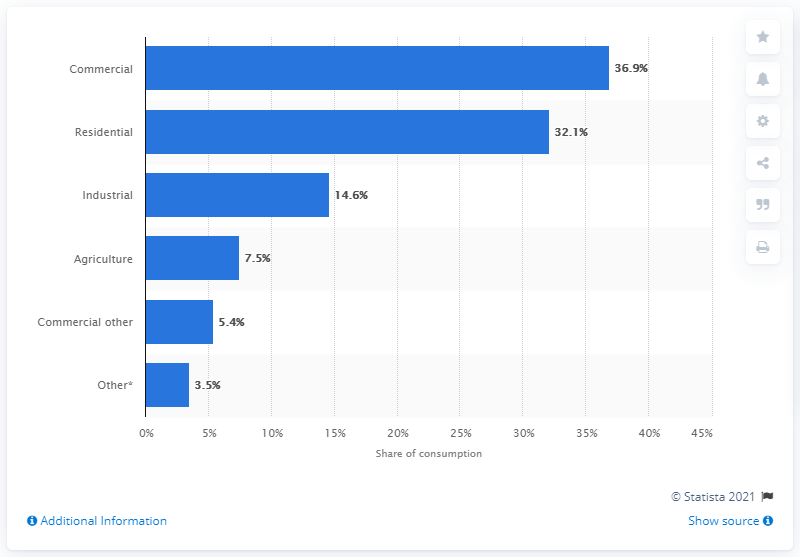Give some essential details in this illustration. In 2016, residential consumption accounted for 32.1% of California's total electricity consumption. 